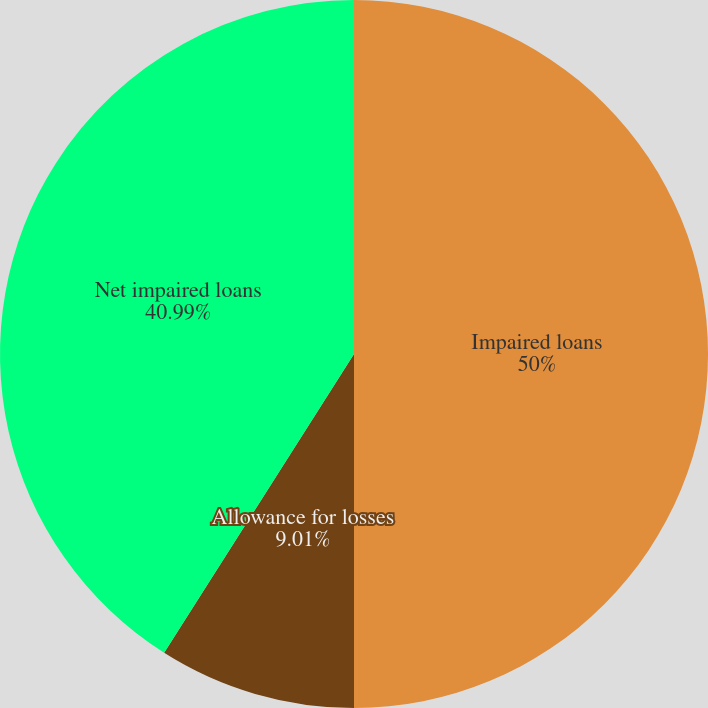Convert chart to OTSL. <chart><loc_0><loc_0><loc_500><loc_500><pie_chart><fcel>Impaired loans<fcel>Allowance for losses<fcel>Net impaired loans<nl><fcel>50.0%<fcel>9.01%<fcel>40.99%<nl></chart> 